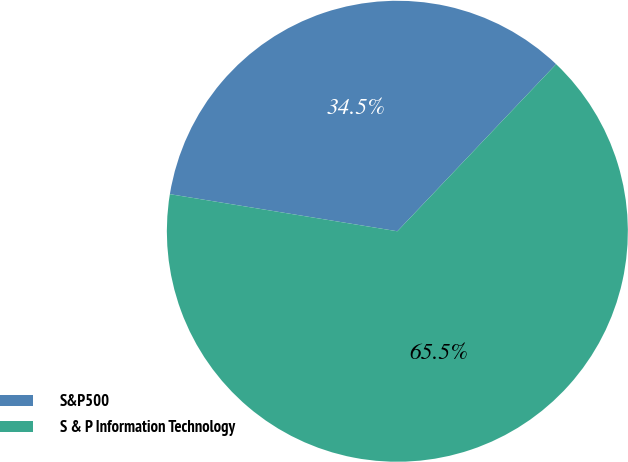<chart> <loc_0><loc_0><loc_500><loc_500><pie_chart><fcel>S&P500<fcel>S & P Information Technology<nl><fcel>34.52%<fcel>65.48%<nl></chart> 